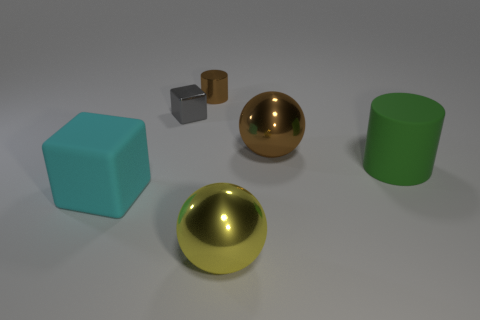What number of other things are there of the same color as the rubber cylinder?
Keep it short and to the point. 0. Is the size of the cylinder on the left side of the green rubber thing the same as the yellow sphere?
Offer a terse response. No. Do the cylinder that is behind the gray metal thing and the thing right of the big brown ball have the same material?
Ensure brevity in your answer.  No. Are there any yellow metal cubes that have the same size as the gray metallic object?
Ensure brevity in your answer.  No. What shape is the rubber object that is on the right side of the metal ball that is behind the cube that is to the left of the metal block?
Your response must be concise. Cylinder. Are there more metallic spheres that are behind the green rubber object than tiny green balls?
Your answer should be very brief. Yes. Are there any tiny brown metal objects of the same shape as the large green object?
Keep it short and to the point. Yes. Are the large yellow sphere and the big ball right of the yellow ball made of the same material?
Offer a terse response. Yes. What is the color of the matte cylinder?
Provide a short and direct response. Green. There is a green thing behind the block left of the tiny cube; how many big brown metal things are in front of it?
Provide a short and direct response. 0. 